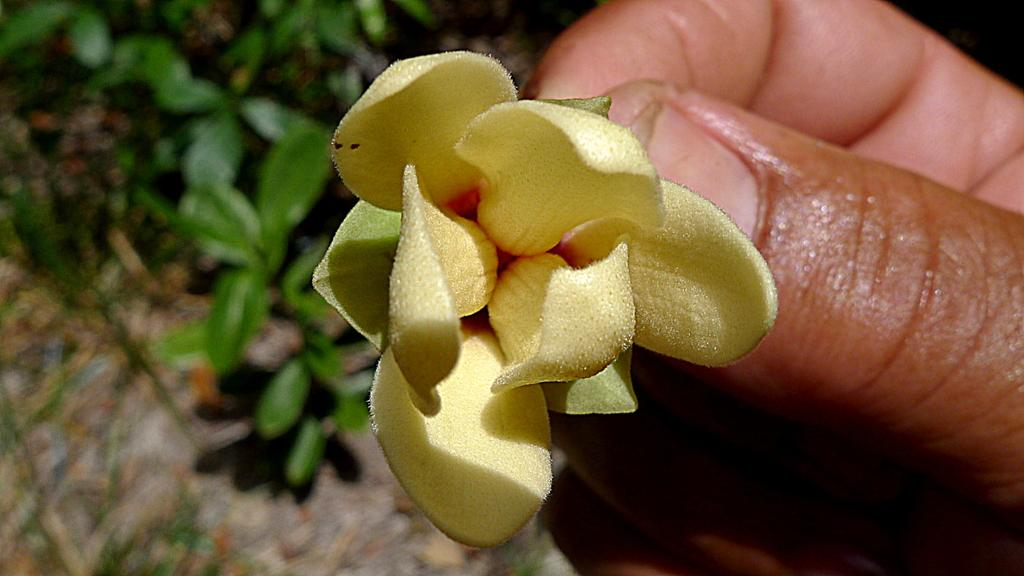What is the person holding in the image? There is a flower in the person's hand. What can be seen in the background of the image? There are plants in the background of the image. How would you describe the background of the image? The background of the image is blurred. What type of lipstick is the person wearing in the image? There is no lipstick or any indication of the person's lips visible in the image. 